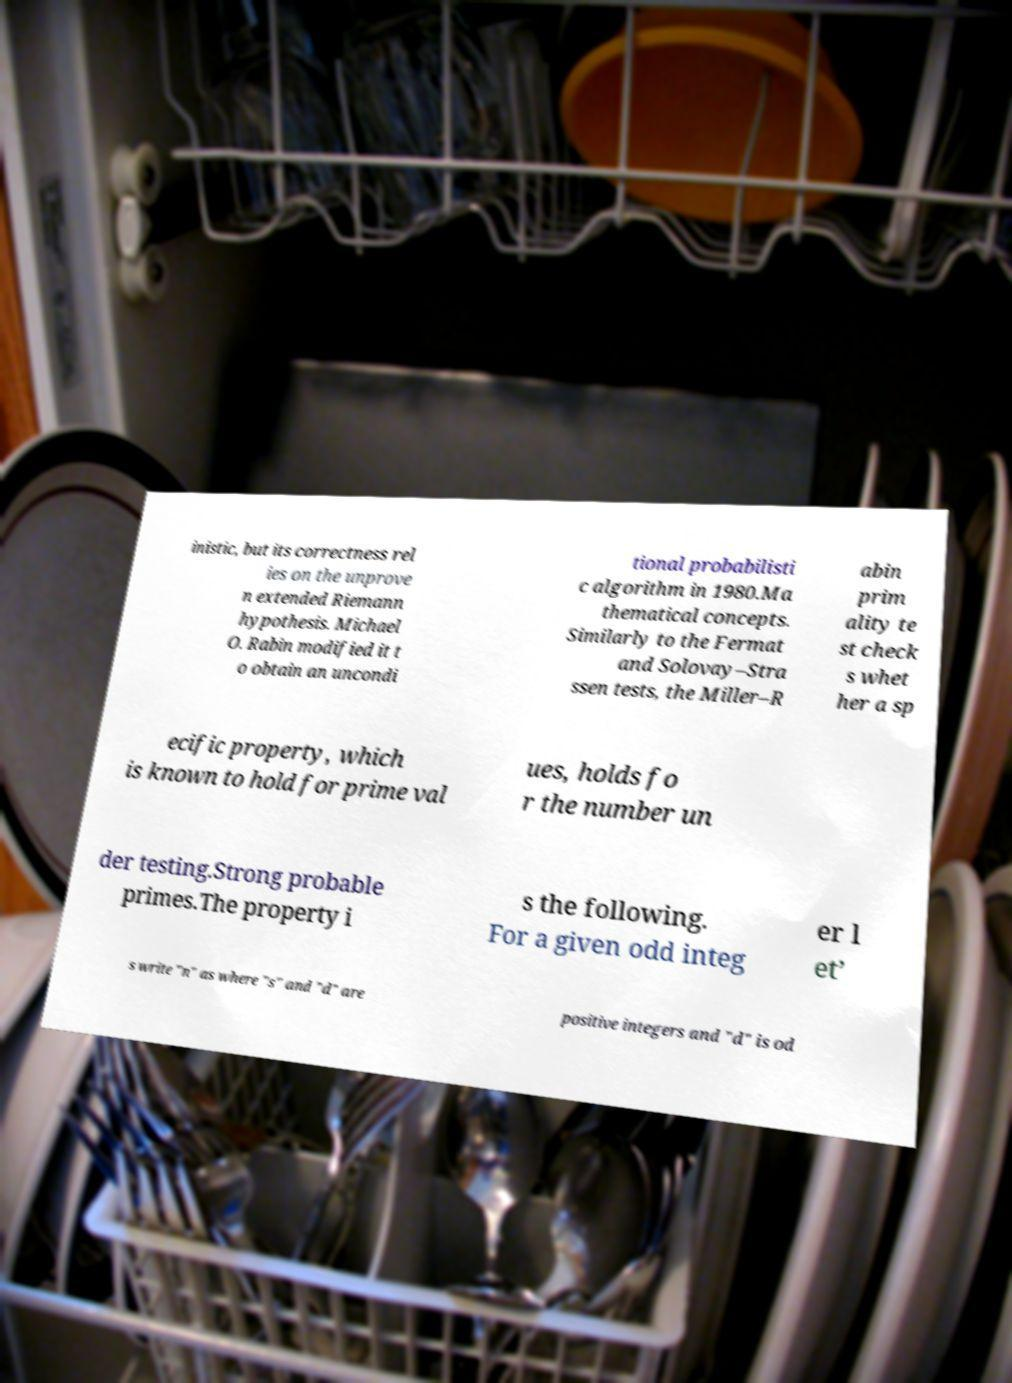I need the written content from this picture converted into text. Can you do that? inistic, but its correctness rel ies on the unprove n extended Riemann hypothesis. Michael O. Rabin modified it t o obtain an uncondi tional probabilisti c algorithm in 1980.Ma thematical concepts. Similarly to the Fermat and Solovay–Stra ssen tests, the Miller–R abin prim ality te st check s whet her a sp ecific property, which is known to hold for prime val ues, holds fo r the number un der testing.Strong probable primes.The property i s the following. For a given odd integ er l et’ s write "n" as where "s" and "d" are positive integers and "d" is od 